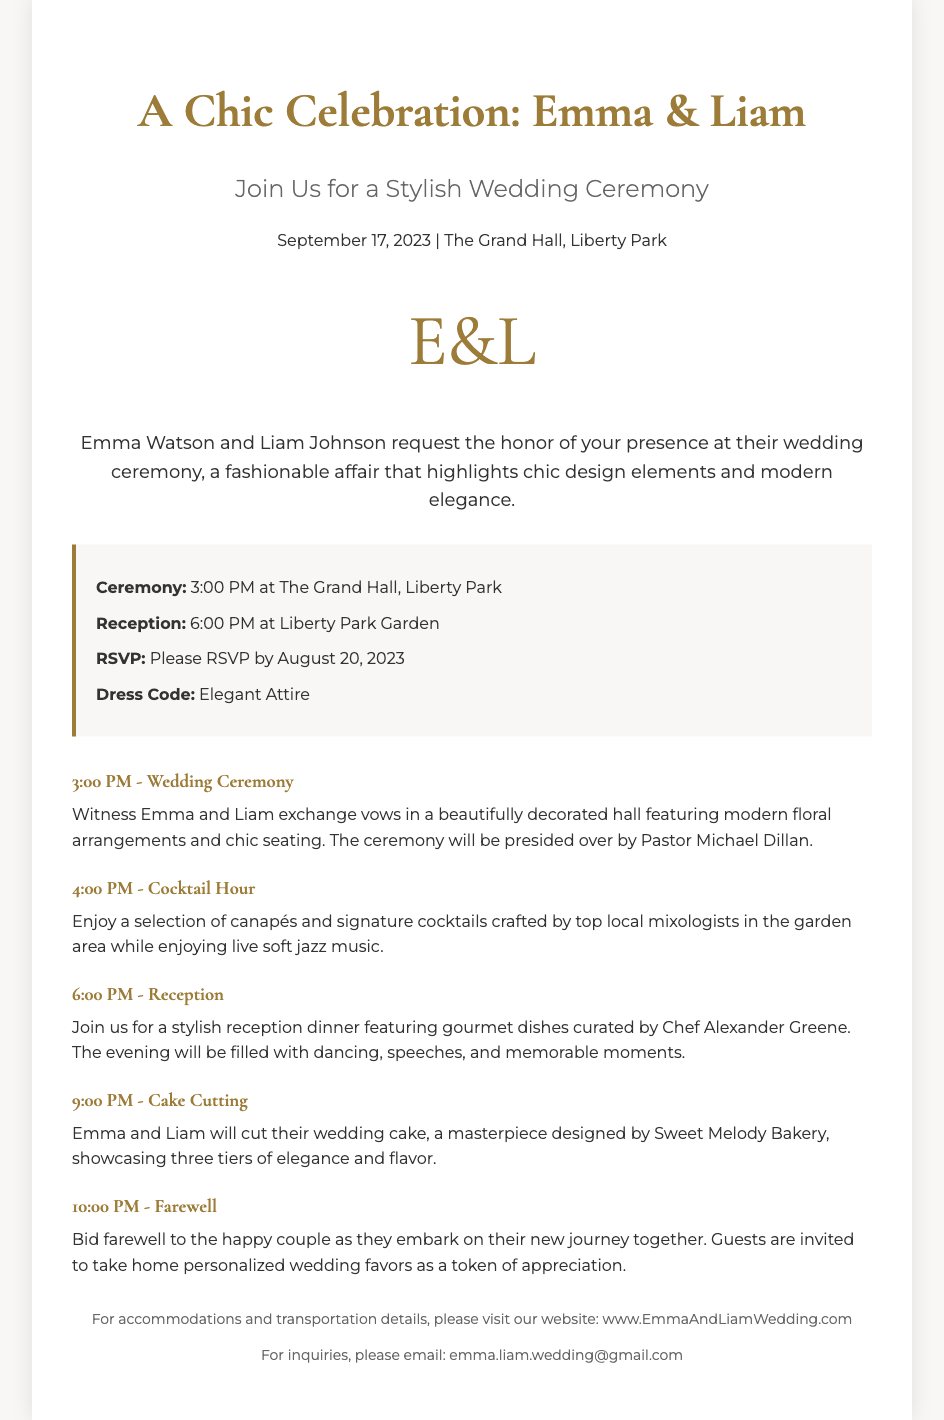What is the couple's names? The document states the couple's names are Emma Watson and Liam Johnson.
Answer: Emma Watson and Liam Johnson What is the date of the wedding ceremony? The date mentioned in the invitation is September 17, 2023.
Answer: September 17, 2023 What is the dress code for the wedding? The dress code specified in the details section is "Elegant Attire."
Answer: Elegant Attire What time does the reception start? According to the details, the reception starts at 6:00 PM.
Answer: 6:00 PM Who presides over the wedding ceremony? The document mentions Pastor Michael Dillan as the officiant of the ceremony.
Answer: Pastor Michael Dillan What type of music will be played during the cocktail hour? The itinerary describes the music during the cocktail hour as live soft jazz.
Answer: live soft jazz What is included in the cake cutting event? It mentions that Emma and Liam will cut their wedding cake designed by Sweet Melody Bakery.
Answer: wedding cake What should guests take home as a token of appreciation? The document states that guests are invited to take home personalized wedding favors.
Answer: personalized wedding favors 